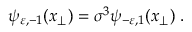<formula> <loc_0><loc_0><loc_500><loc_500>\psi _ { \varepsilon , - 1 } ( x _ { \perp } ) = \sigma ^ { 3 } \psi _ { - \varepsilon , 1 } ( x _ { \perp } ) \, .</formula> 